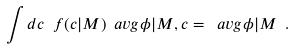Convert formula to latex. <formula><loc_0><loc_0><loc_500><loc_500>\int d c \ f ( c | M ) \ a v g { \phi | M , c } = \ a v g { \phi | M } \ .</formula> 